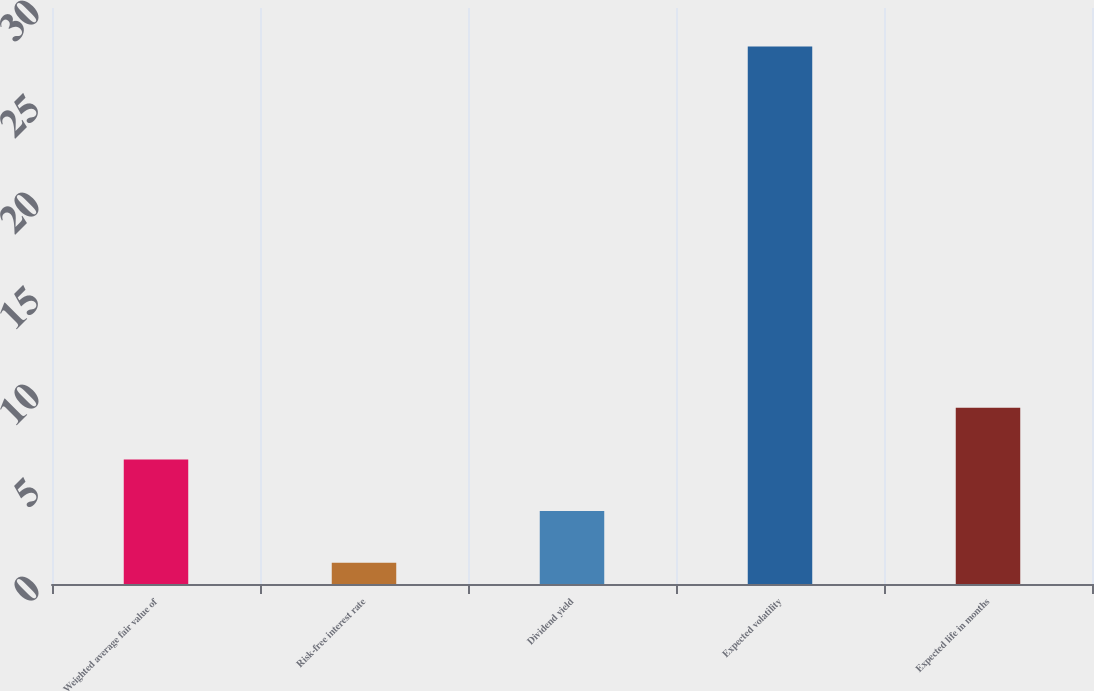Convert chart to OTSL. <chart><loc_0><loc_0><loc_500><loc_500><bar_chart><fcel>Weighted average fair value of<fcel>Risk-free interest rate<fcel>Dividend yield<fcel>Expected volatility<fcel>Expected life in months<nl><fcel>6.49<fcel>1.11<fcel>3.8<fcel>28<fcel>9.18<nl></chart> 